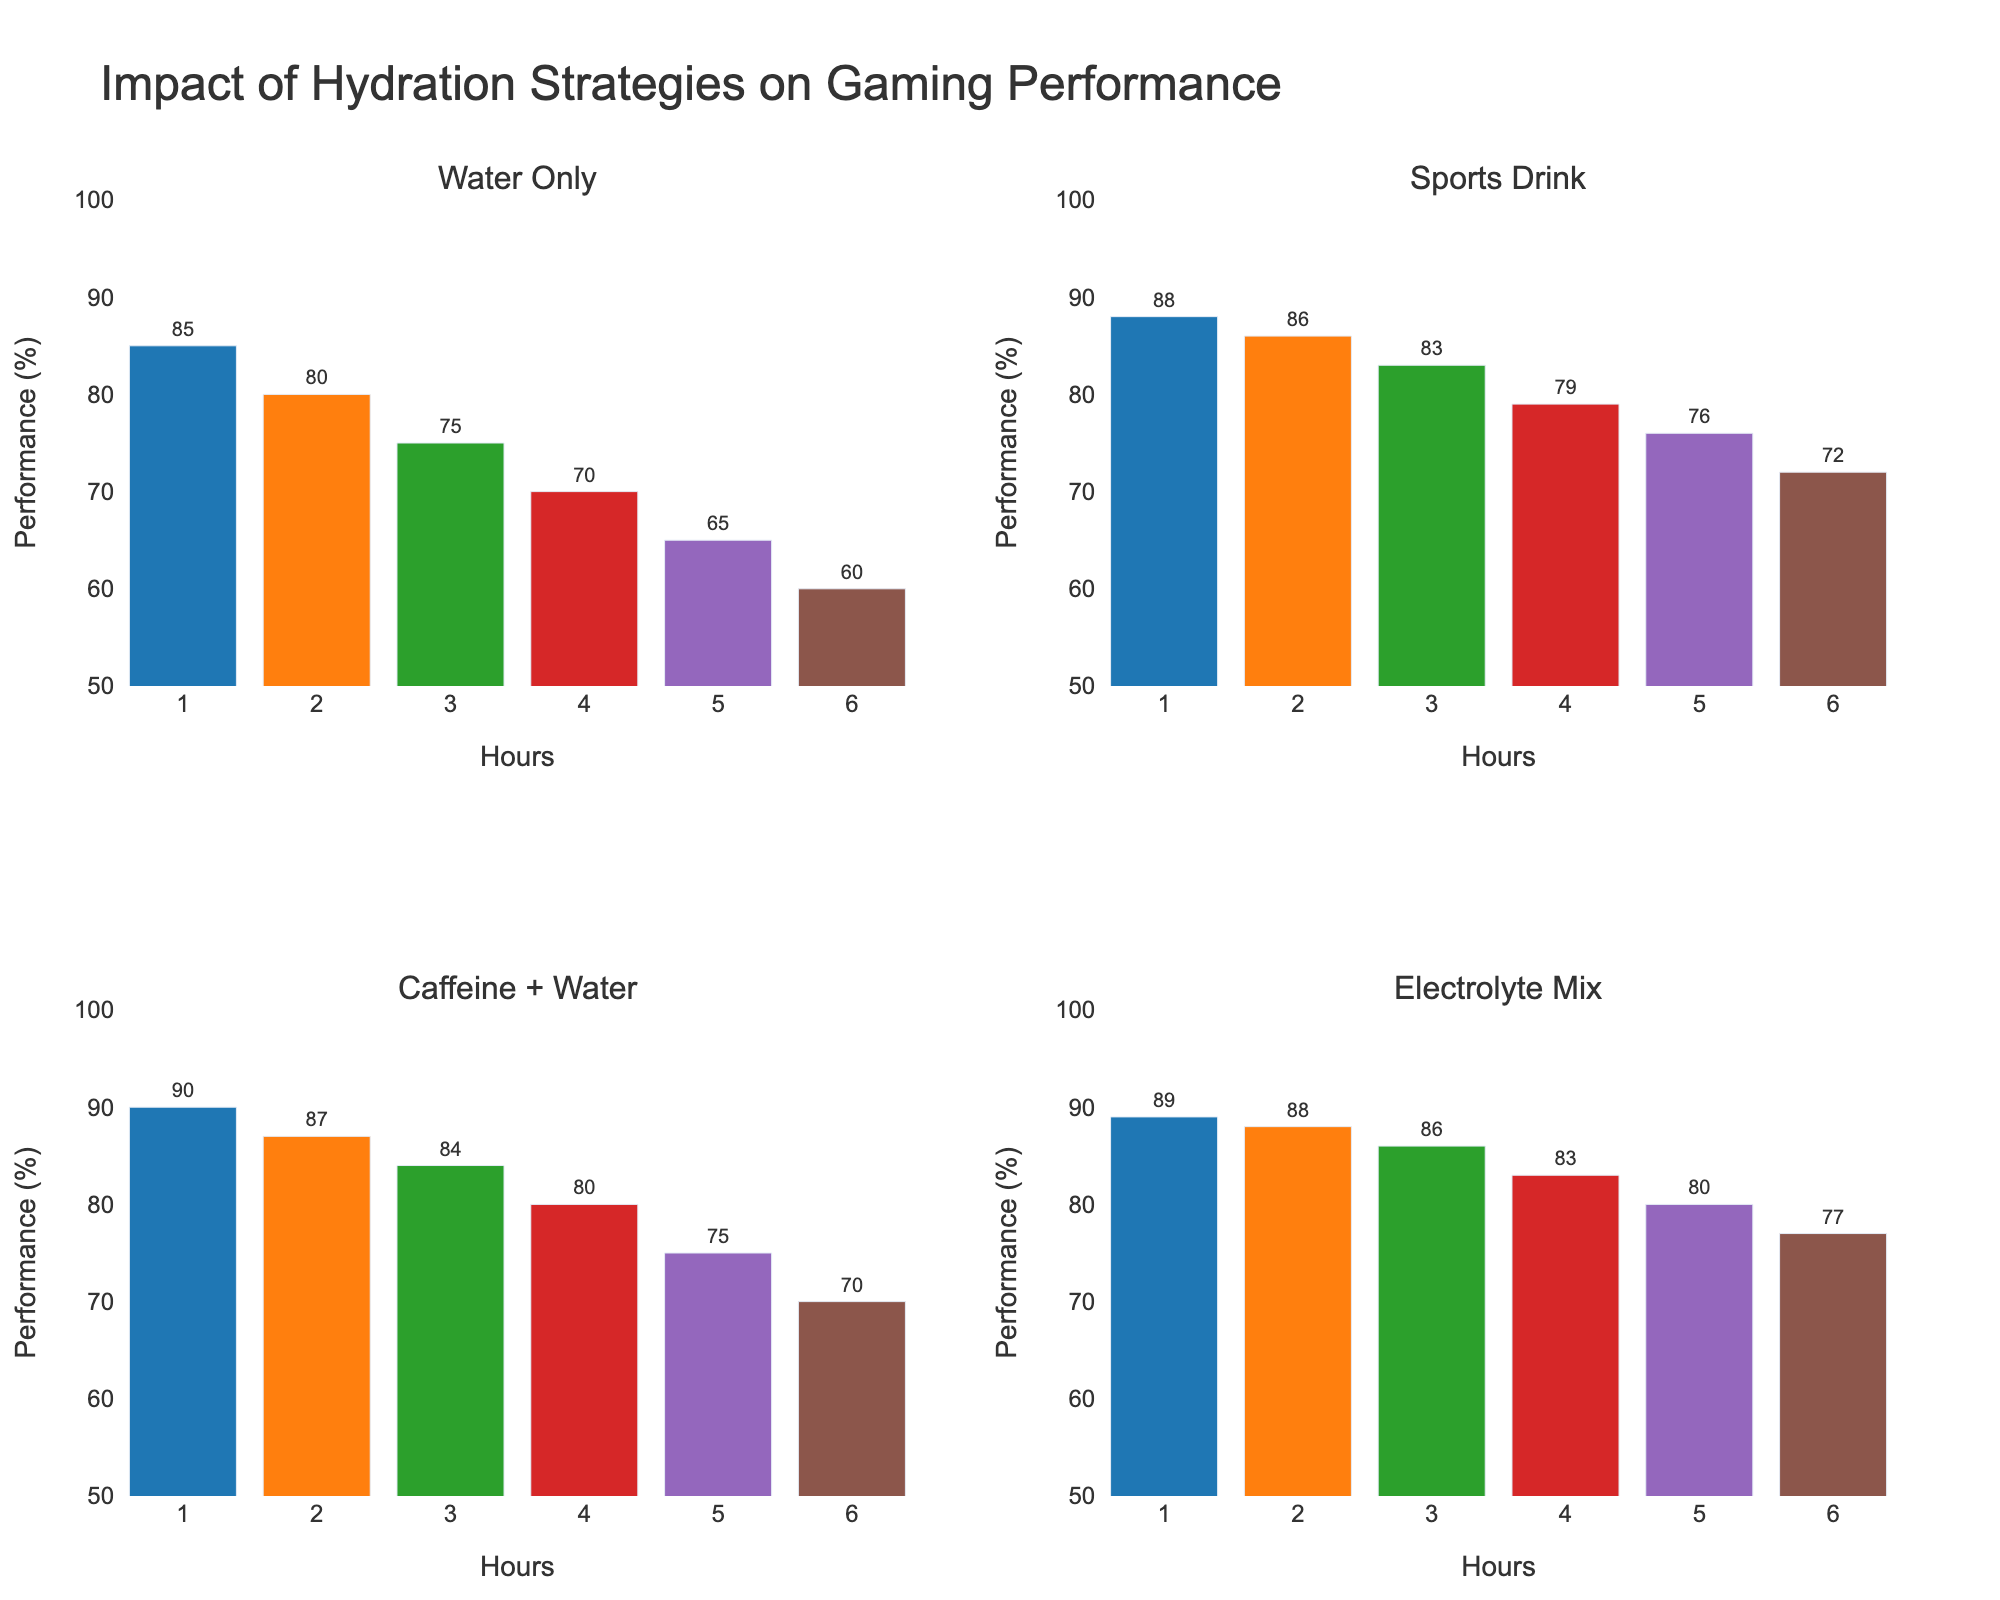What is the title of the figure? The title of the figure can be found at the top of the overall layout.
Answer: Impact of Hydration Strategies on Gaming Performance Which hydration strategy shows the highest performance at Hour 1? The highest bar in the first column for Hour 1 indicates the strategy with the highest performance.
Answer: Caffeine + Water How does the performance of 'Sports Drink' change from Hour 1 to Hour 6? Observe the height of the bars for 'Sports Drink' from Hour 1 to Hour 6, noting the difference in percentage.
Answer: It decreases from 88% to 72% Compare the performance of 'Electrolyte Mix' and 'Water Only' at Hour 3. Which one is better? Compare the heights of the bars for 'Electrolyte Mix' and 'Water Only' at Hour 3.
Answer: Electrolyte Mix Which strategy shows the smallest decline in performance percentage from Hour 1 to Hour 6? Calculate the difference in performance from Hour 1 to Hour 6 for each strategy and find the smallest decrease.
Answer: Electrolyte Mix What's the performance difference between 'Caffeine + Water' and 'Sports Drink' at Hour 2? Subtract the performance percentage of 'Sports Drink' from 'Caffeine + Water' at Hour 2.
Answer: 1% Which hydration strategy maintains a performance level above 80% for the longest duration? Identify the strategy that stays above 80% from Hour 1 onwards for the most hours.
Answer: Electrolyte Mix What is the average performance of 'Water Only' across all hours? Add the performance percentages for all hours and divide by the number of hours. (85 + 80 + 75 + 70 + 65 + 60) / 6
Answer: 72.5% Is there any strategy that performs worse than 70% at Hour 5? Check each strategy’s bar height at Hour 5 to see if any are below 70%.
Answer: No 